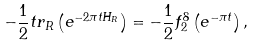<formula> <loc_0><loc_0><loc_500><loc_500>- \frac { 1 } { 2 } t r _ { R } \left ( e ^ { - 2 \pi t H _ { R } } \right ) = - \frac { 1 } { 2 } f _ { 2 } ^ { 8 } \left ( e ^ { - \pi t } \right ) ,</formula> 